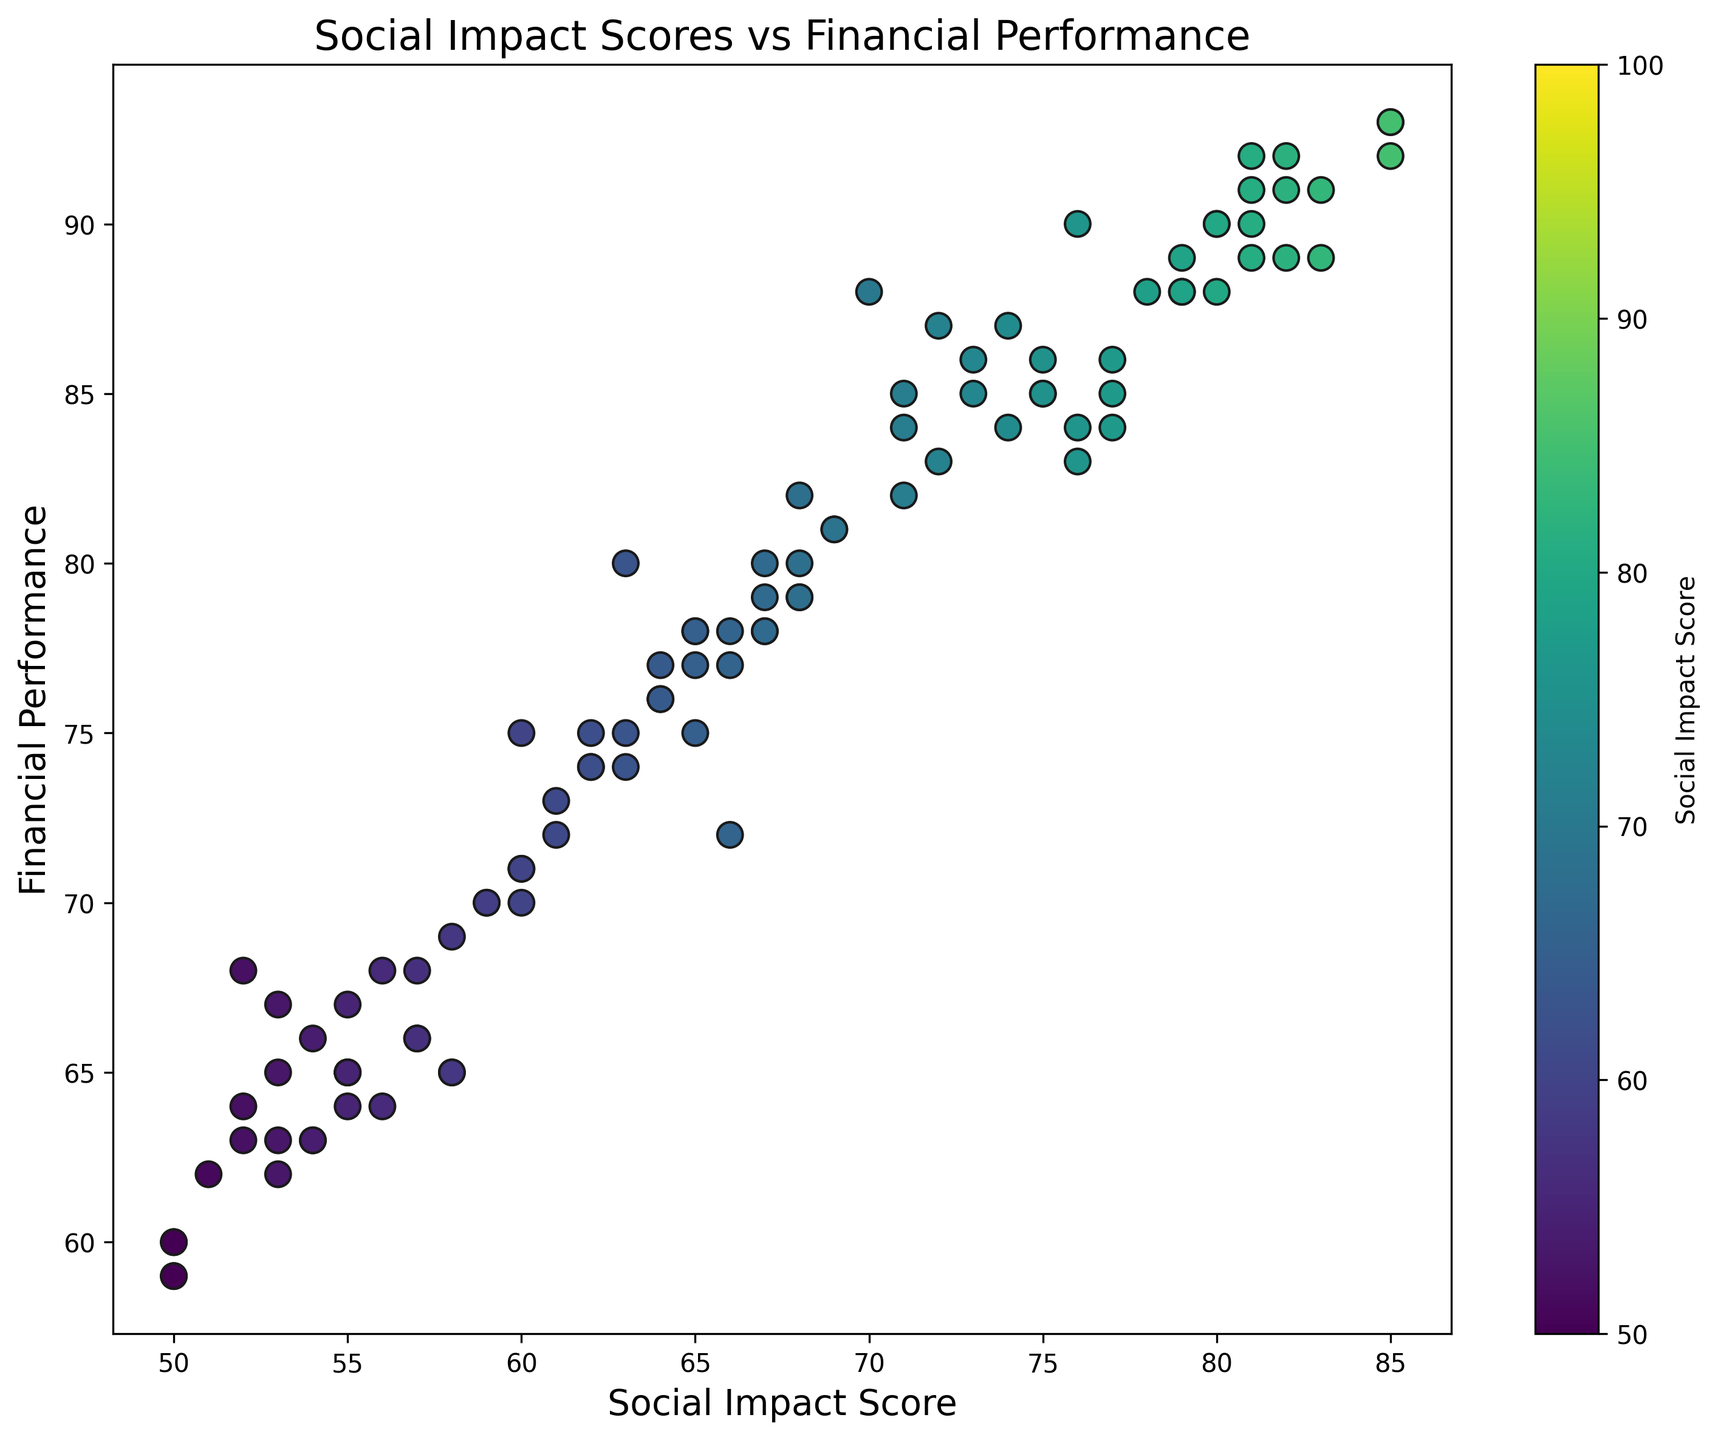What is the range of Social Impact Scores in the dataset? To determine the range of the Social Impact Scores, identify the minimum and maximum scores from the data. The minimum Social Impact Score is 50, and the maximum is 85. The range is calculated as 85 - 50.
Answer: 35 Which company has the highest Financial Performance? From the scatter plot, identify the point that corresponds to the highest Financial Performance score. According to the data, the maximum Financial Performance score is 93, recorded by Company30 and Company98.
Answer: Company30 or Company98 How many companies have a Social Impact Score above 80? Count the points in the scatter plot where the Social Impact Score is greater than 80. The companies with scores above 80 are Company3, Company7, Company17, Company27, Company30, Company34, Company43, Company56, Company59, Company74, Company77, Company80, Company90, and Company94, resulting in a total of 14 companies.
Answer: 14 What is the average Financial Performance of companies with a Social Impact Score between 70 and 75? First, identify the companies with Social Impact Scores between 70 and 75: Company5, Company13, Company15, Company20, Company25, Company38, Company51, Company66, Company65, Company57, Company83, and Company85. Then calculate their average Financial Performance: (88+84+87+86+84+90+85+84+85+81+87+86)/12
Answer: 85.5 Is there a visible trend between Social Impact Scores and Financial Performance in the scatter plot? Examine the scatter plot to determine if there is a pattern between the Social Impact Scores and Financial Performance. Points with higher Social Impact Scores generally appear towards the higher end of Financial Performance, indicating a positive correlation.
Answer: Yes, there is a positive correlation Which companies are outliers with a Social Impact Score below 55 and a Financial Performance above 70? Look for points in the scatter plot that meet the criteria of a Social Impact Score below 55 and a Financial Performance above 70. There are no companies in the dataset that satisfy both conditions simultaneously.
Answer: None What is the median Financial Performance score of all companies? Rank all the Financial Performance scores and identify the middle value. Since there are 100 companies (an even number), the median is the average of the 50th and 51st ranked scores. The 50th and 51st Financial Performance scores are both 75.
Answer: 75 